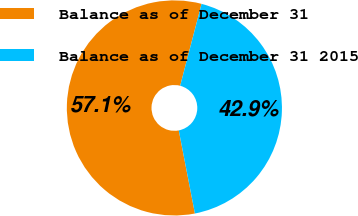<chart> <loc_0><loc_0><loc_500><loc_500><pie_chart><fcel>Balance as of December 31<fcel>Balance as of December 31 2015<nl><fcel>57.12%<fcel>42.88%<nl></chart> 